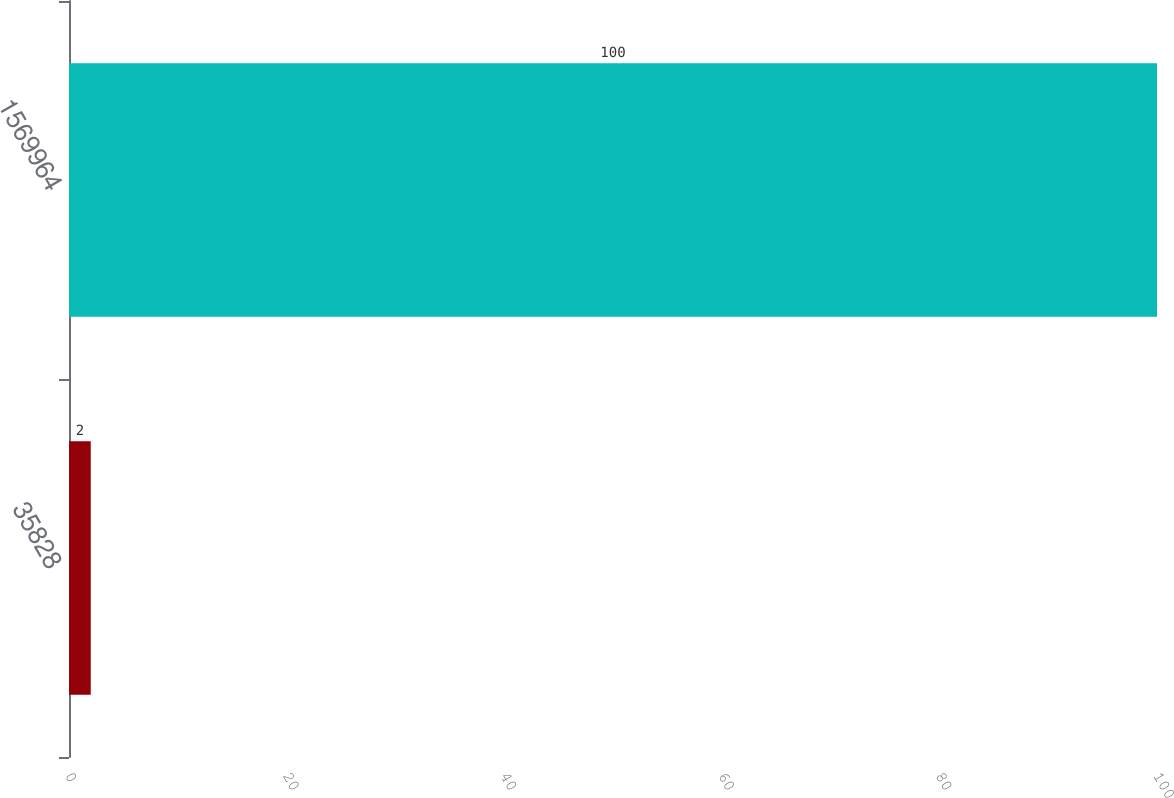<chart> <loc_0><loc_0><loc_500><loc_500><bar_chart><fcel>35828<fcel>1569964<nl><fcel>2<fcel>100<nl></chart> 